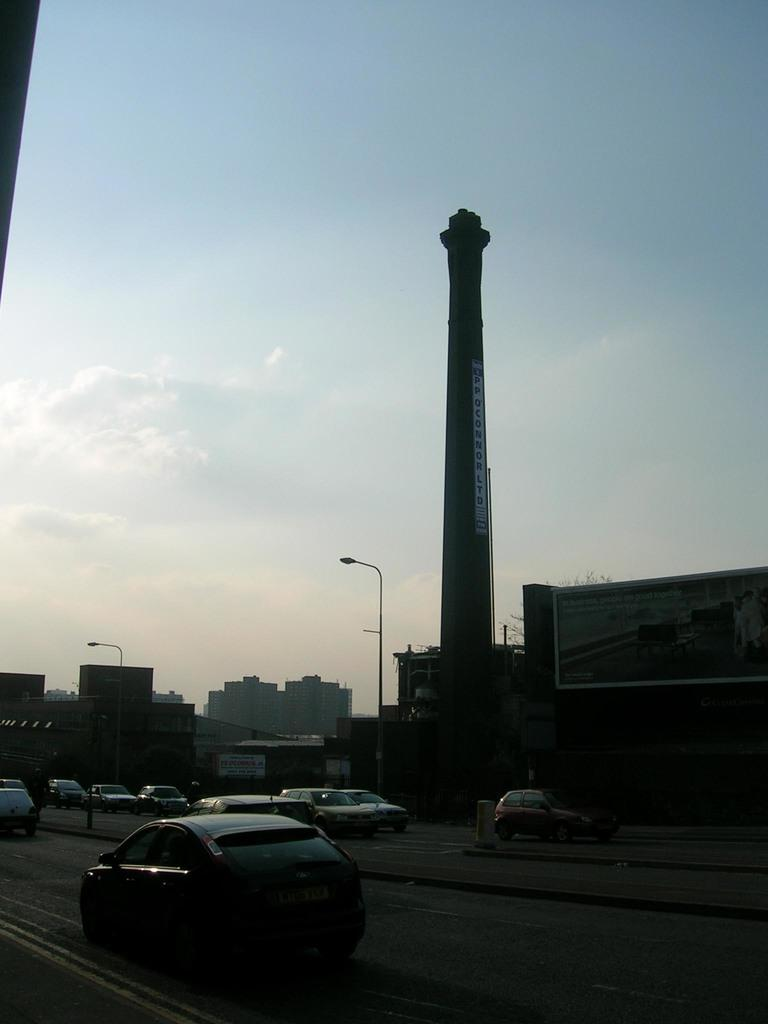What type of vehicles can be seen on the road in the image? There are cars on the road in the image. What structures are visible in the image? There are buildings in the image. What else can be seen in the image besides cars and buildings? There are poles in the image. What is visible in the background of the image? The sky is visible in the background of the image. What can be observed in the sky in the image? Clouds are present in the sky. Can you tell me what type of fiction the cook is reading in the image? There is no cook or fiction present in the image. What role does the secretary play in the image? There is no secretary present in the image. 